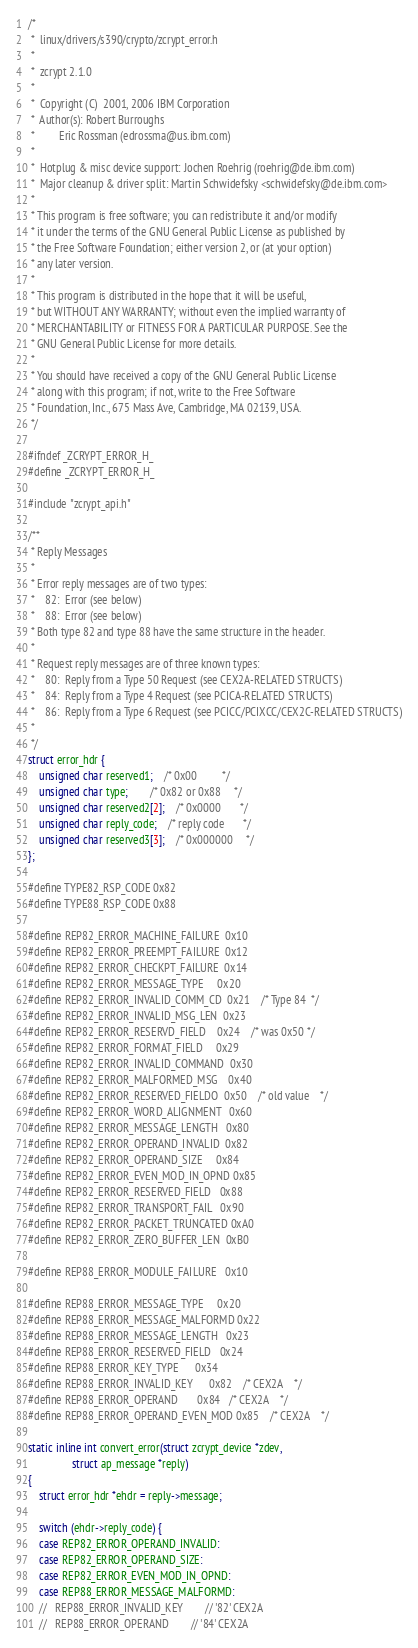<code> <loc_0><loc_0><loc_500><loc_500><_C_>/*
 *  linux/drivers/s390/crypto/zcrypt_error.h
 *
 *  zcrypt 2.1.0
 *
 *  Copyright (C)  2001, 2006 IBM Corporation
 *  Author(s): Robert Burroughs
 *	       Eric Rossman (edrossma@us.ibm.com)
 *
 *  Hotplug & misc device support: Jochen Roehrig (roehrig@de.ibm.com)
 *  Major cleanup & driver split: Martin Schwidefsky <schwidefsky@de.ibm.com>
 *
 * This program is free software; you can redistribute it and/or modify
 * it under the terms of the GNU General Public License as published by
 * the Free Software Foundation; either version 2, or (at your option)
 * any later version.
 *
 * This program is distributed in the hope that it will be useful,
 * but WITHOUT ANY WARRANTY; without even the implied warranty of
 * MERCHANTABILITY or FITNESS FOR A PARTICULAR PURPOSE. See the
 * GNU General Public License for more details.
 *
 * You should have received a copy of the GNU General Public License
 * along with this program; if not, write to the Free Software
 * Foundation, Inc., 675 Mass Ave, Cambridge, MA 02139, USA.
 */

#ifndef _ZCRYPT_ERROR_H_
#define _ZCRYPT_ERROR_H_

#include "zcrypt_api.h"

/**
 * Reply Messages
 *
 * Error reply messages are of two types:
 *    82:  Error (see below)
 *    88:  Error (see below)
 * Both type 82 and type 88 have the same structure in the header.
 *
 * Request reply messages are of three known types:
 *    80:  Reply from a Type 50 Request (see CEX2A-RELATED STRUCTS)
 *    84:  Reply from a Type 4 Request (see PCICA-RELATED STRUCTS)
 *    86:  Reply from a Type 6 Request (see PCICC/PCIXCC/CEX2C-RELATED STRUCTS)
 *
 */
struct error_hdr {
	unsigned char reserved1;	/* 0x00			*/
	unsigned char type;		/* 0x82 or 0x88		*/
	unsigned char reserved2[2];	/* 0x0000		*/
	unsigned char reply_code;	/* reply code		*/
	unsigned char reserved3[3];	/* 0x000000		*/
};

#define TYPE82_RSP_CODE 0x82
#define TYPE88_RSP_CODE 0x88

#define REP82_ERROR_MACHINE_FAILURE  0x10
#define REP82_ERROR_PREEMPT_FAILURE  0x12
#define REP82_ERROR_CHECKPT_FAILURE  0x14
#define REP82_ERROR_MESSAGE_TYPE     0x20
#define REP82_ERROR_INVALID_COMM_CD  0x21	/* Type 84	*/
#define REP82_ERROR_INVALID_MSG_LEN  0x23
#define REP82_ERROR_RESERVD_FIELD    0x24	/* was 0x50	*/
#define REP82_ERROR_FORMAT_FIELD     0x29
#define REP82_ERROR_INVALID_COMMAND  0x30
#define REP82_ERROR_MALFORMED_MSG    0x40
#define REP82_ERROR_RESERVED_FIELDO  0x50	/* old value	*/
#define REP82_ERROR_WORD_ALIGNMENT   0x60
#define REP82_ERROR_MESSAGE_LENGTH   0x80
#define REP82_ERROR_OPERAND_INVALID  0x82
#define REP82_ERROR_OPERAND_SIZE     0x84
#define REP82_ERROR_EVEN_MOD_IN_OPND 0x85
#define REP82_ERROR_RESERVED_FIELD   0x88
#define REP82_ERROR_TRANSPORT_FAIL   0x90
#define REP82_ERROR_PACKET_TRUNCATED 0xA0
#define REP82_ERROR_ZERO_BUFFER_LEN  0xB0

#define REP88_ERROR_MODULE_FAILURE   0x10

#define REP88_ERROR_MESSAGE_TYPE     0x20
#define REP88_ERROR_MESSAGE_MALFORMD 0x22
#define REP88_ERROR_MESSAGE_LENGTH   0x23
#define REP88_ERROR_RESERVED_FIELD   0x24
#define REP88_ERROR_KEY_TYPE	     0x34
#define REP88_ERROR_INVALID_KEY      0x82	/* CEX2A	*/
#define REP88_ERROR_OPERAND	     0x84	/* CEX2A	*/
#define REP88_ERROR_OPERAND_EVEN_MOD 0x85	/* CEX2A	*/

static inline int convert_error(struct zcrypt_device *zdev,
				struct ap_message *reply)
{
	struct error_hdr *ehdr = reply->message;

	switch (ehdr->reply_code) {
	case REP82_ERROR_OPERAND_INVALID:
	case REP82_ERROR_OPERAND_SIZE:
	case REP82_ERROR_EVEN_MOD_IN_OPND:
	case REP88_ERROR_MESSAGE_MALFORMD:
	//   REP88_ERROR_INVALID_KEY		// '82' CEX2A
	//   REP88_ERROR_OPERAND		// '84' CEX2A</code> 